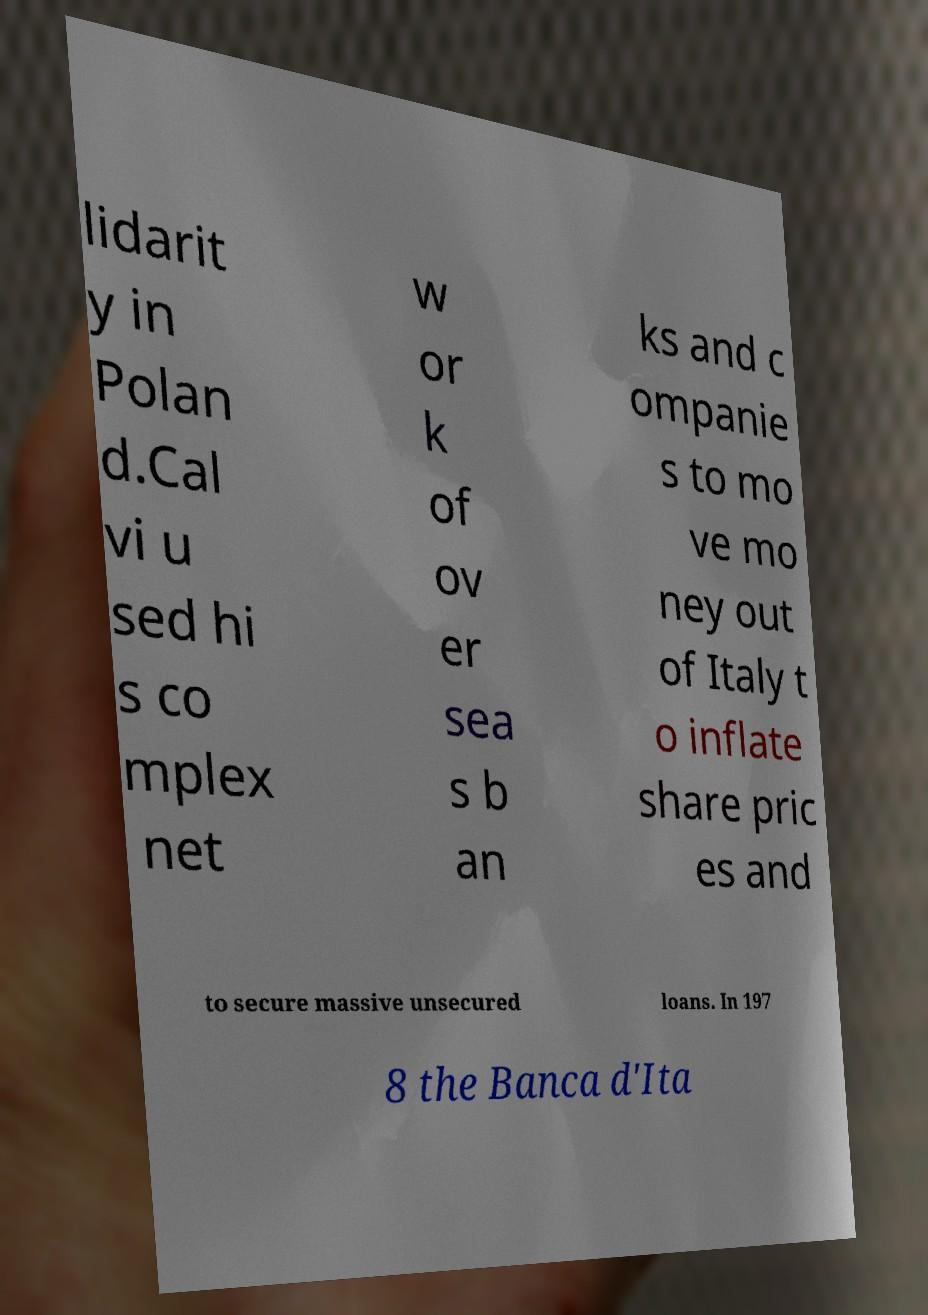For documentation purposes, I need the text within this image transcribed. Could you provide that? lidarit y in Polan d.Cal vi u sed hi s co mplex net w or k of ov er sea s b an ks and c ompanie s to mo ve mo ney out of Italy t o inflate share pric es and to secure massive unsecured loans. In 197 8 the Banca d'Ita 